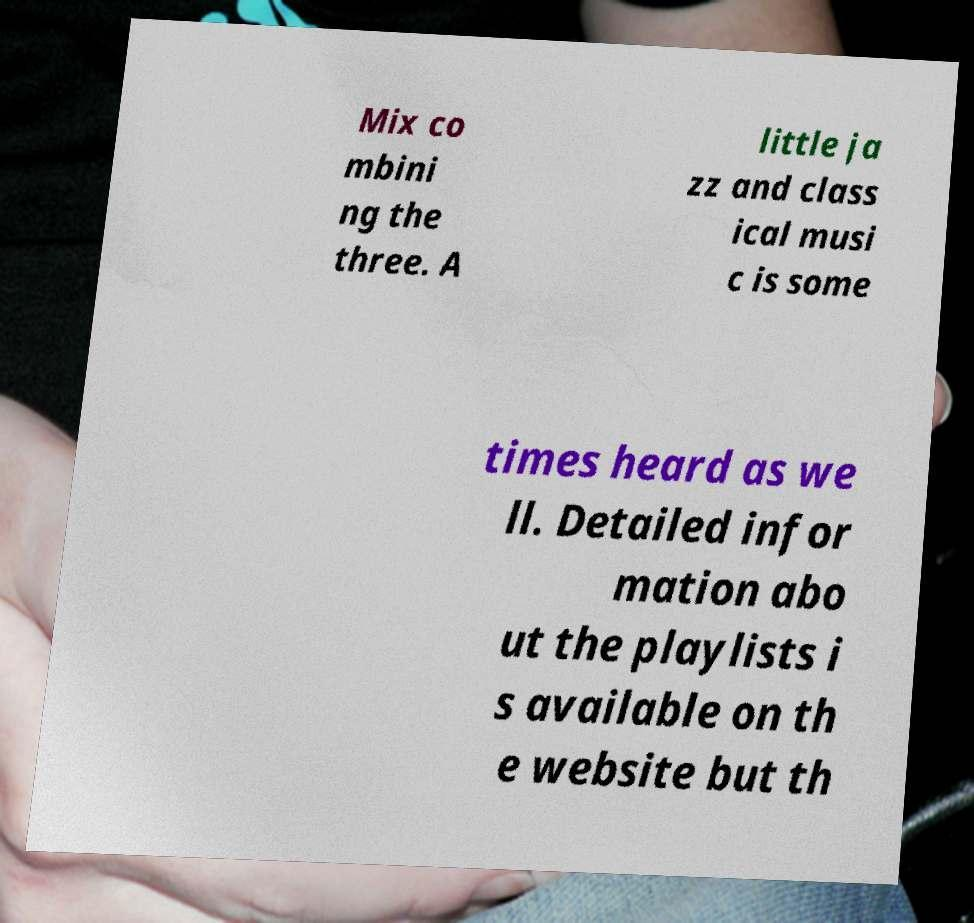Please identify and transcribe the text found in this image. Mix co mbini ng the three. A little ja zz and class ical musi c is some times heard as we ll. Detailed infor mation abo ut the playlists i s available on th e website but th 